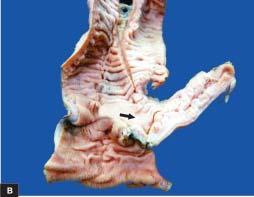what does the lumen contain?
Answer the question using a single word or phrase. Necrotic debris 